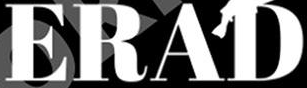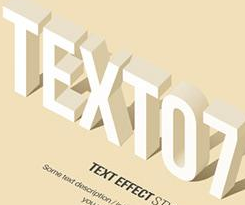Read the text from these images in sequence, separated by a semicolon. ERAD; TEXTO7 